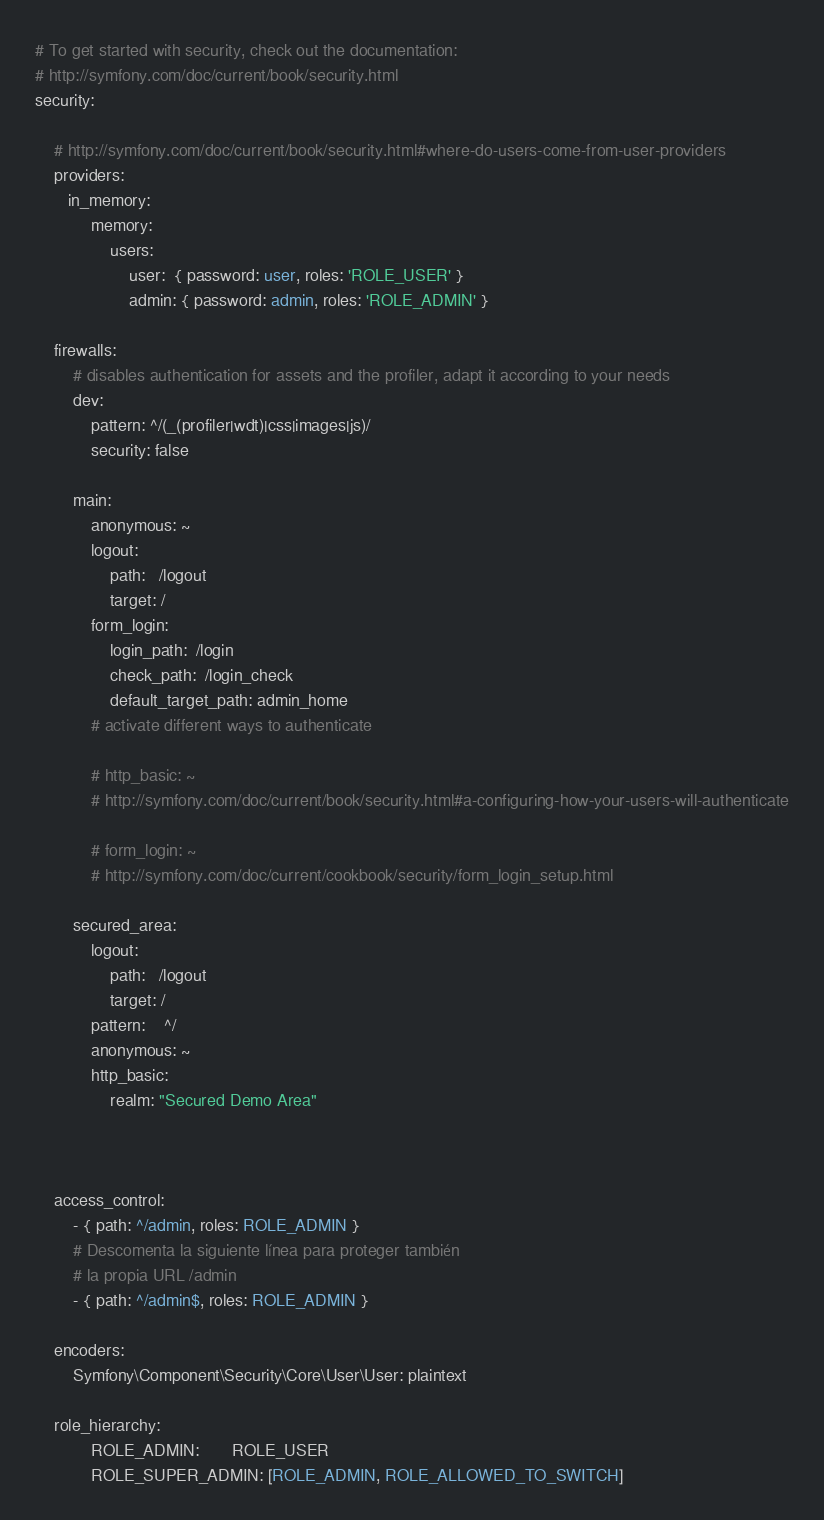Convert code to text. <code><loc_0><loc_0><loc_500><loc_500><_YAML_># To get started with security, check out the documentation:
# http://symfony.com/doc/current/book/security.html
security:

    # http://symfony.com/doc/current/book/security.html#where-do-users-come-from-user-providers
    providers:
       in_memory:
            memory:
                users:
                    user:  { password: user, roles: 'ROLE_USER' }
                    admin: { password: admin, roles: 'ROLE_ADMIN' }

    firewalls:
        # disables authentication for assets and the profiler, adapt it according to your needs
        dev:
            pattern: ^/(_(profiler|wdt)|css|images|js)/
            security: false

        main:
            anonymous: ~
            logout:
                path:   /logout
                target: /
            form_login:
                login_path:  /login
                check_path:  /login_check
                default_target_path: admin_home
            # activate different ways to authenticate

            # http_basic: ~
            # http://symfony.com/doc/current/book/security.html#a-configuring-how-your-users-will-authenticate

            # form_login: ~
            # http://symfony.com/doc/current/cookbook/security/form_login_setup.html

        secured_area:
            logout:
                path:   /logout
                target: /
            pattern:    ^/
            anonymous: ~
            http_basic:
                realm: "Secured Demo Area"



    access_control:
        - { path: ^/admin, roles: ROLE_ADMIN }
        # Descomenta la siguiente línea para proteger también
        # la propia URL /admin
        - { path: ^/admin$, roles: ROLE_ADMIN }

    encoders:
        Symfony\Component\Security\Core\User\User: plaintext

    role_hierarchy:
            ROLE_ADMIN:       ROLE_USER
            ROLE_SUPER_ADMIN: [ROLE_ADMIN, ROLE_ALLOWED_TO_SWITCH]
</code> 